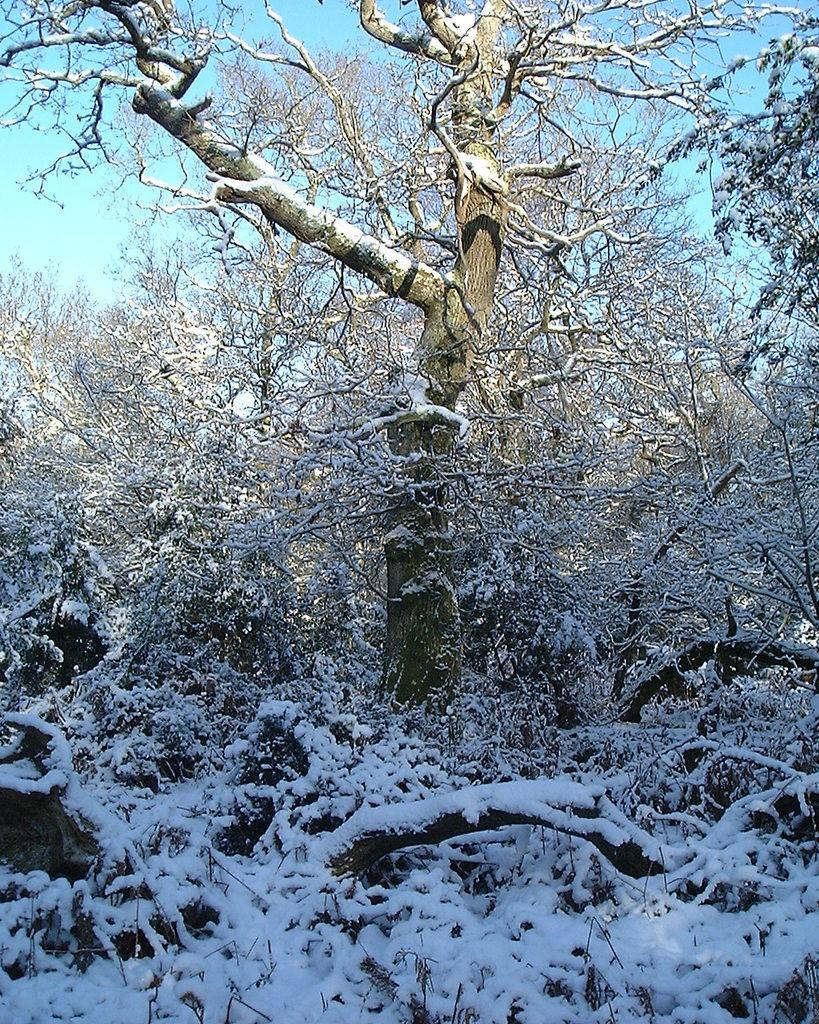What type of vegetation can be seen in the image? There are trees in the image. What is covering the ground in the image? There is snow visible in the image. What part of the natural environment is visible in the image? The ground and the sky are visible in the image. What type of cushion is placed on the committee in the image? There is no committee or cushion present in the image. How many bananas are hanging from the trees in the image? There are no bananas visible in the image; only trees are present. 